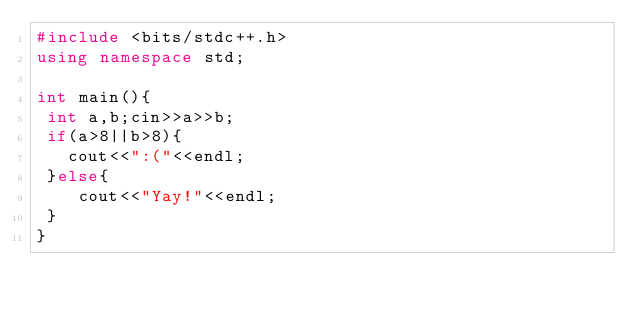<code> <loc_0><loc_0><loc_500><loc_500><_C++_>#include <bits/stdc++.h>
using namespace std;

int main(){
 int a,b;cin>>a>>b;
 if(a>8||b>8){
   cout<<":("<<endl;
 }else{
 	cout<<"Yay!"<<endl;
 }
}
</code> 